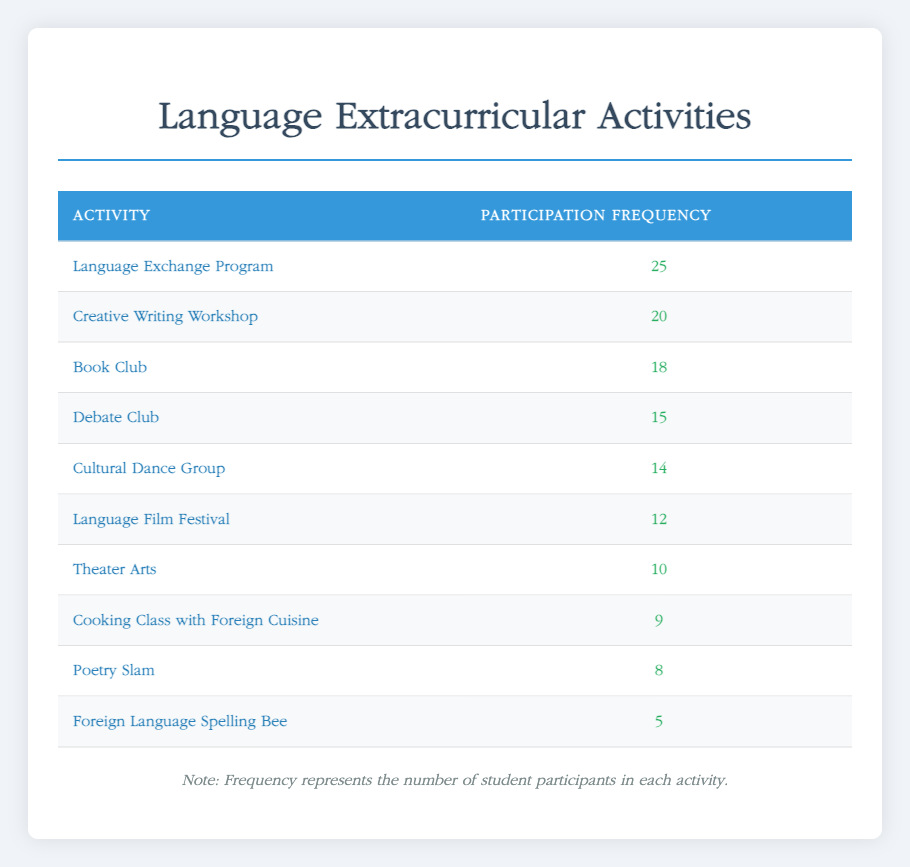What is the activity with the highest participation frequency? The table shows several activities along with their participation frequencies. By scanning the table, we can see that the "Language Exchange Program" has a participation frequency of 25, which is higher than all other activities listed.
Answer: Language Exchange Program How many students participated in the Creative Writing Workshop? The table lists "Creative Writing Workshop" with a participation frequency of 20. This value can be directly retrieved from the table.
Answer: 20 What is the total number of students who participated in all activities combined? To find the total number of participants, we need to add the participation frequencies of all activities: 15 + 25 + 10 + 20 + 18 + 12 + 8 + 5 + 14 + 9 = 126. Therefore, the total participation frequency across all activities is 126.
Answer: 126 Is there more participation in the Debate Club than in the Poetry Slam? The Debate Club has a frequency of 15, while the Poetry Slam has a frequency of 8. Since 15 is greater than 8, it indicates that more students participated in the Debate Club than in the Poetry Slam.
Answer: Yes What is the average participation frequency of the activities? The average is calculated by dividing the total participation frequency (126) by the number of activities (10). So, 126/10 = 12.6. Therefore, the average participation frequency across all activities is 12.6.
Answer: 12.6 Which activity has the lowest participation frequency? The table indicates that the "Foreign Language Spelling Bee" has the lowest participation frequency of 5, which can be directly cited from the information presented.
Answer: Foreign Language Spelling Bee If we compare the frequencies of the Language Film Festival and the Cultural Dance Group, which has more participants? The Language Film Festival has a frequency of 12, while the Cultural Dance Group has 14. Since 14 is greater than 12, it shows that more students participated in the Cultural Dance Group than in the Language Film Festival.
Answer: Cultural Dance Group What is the difference in participation frequency between the Book Club and the Theater Arts? The Book Club has a participation frequency of 18, and Theater Arts has 10. To find the difference, we subtract: 18 - 10 = 8. This calculation shows that there are 8 more participants in the Book Club compared to the Theater Arts.
Answer: 8 Which two activities combined have an equal or greater frequency than the Language Exchange Program? The Language Exchange Program has a frequency of 25. By checking combinations of activities, we can find that the Creative Writing Workshop (20) and Book Club (18) together have frequencies of 20 + 18 = 38, which is greater than 25. Therefore, these two activities combined meet the criteria.
Answer: Creative Writing Workshop and Book Club 